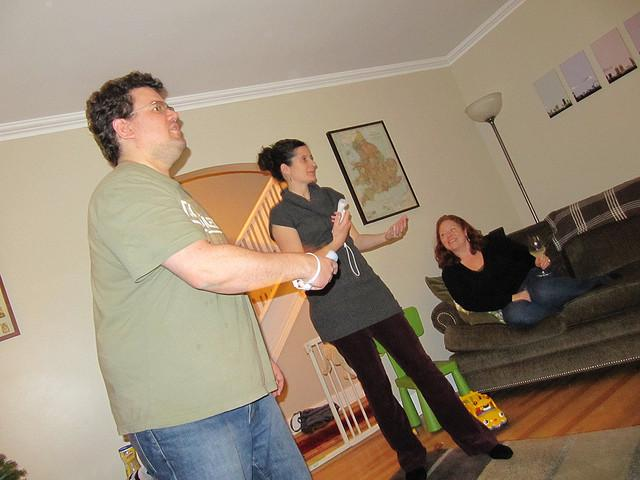What are the majority of the people doing? Please explain your reasoning. standing. All of the people are awake, and nobody is eating. two of the three people are not sitting. 